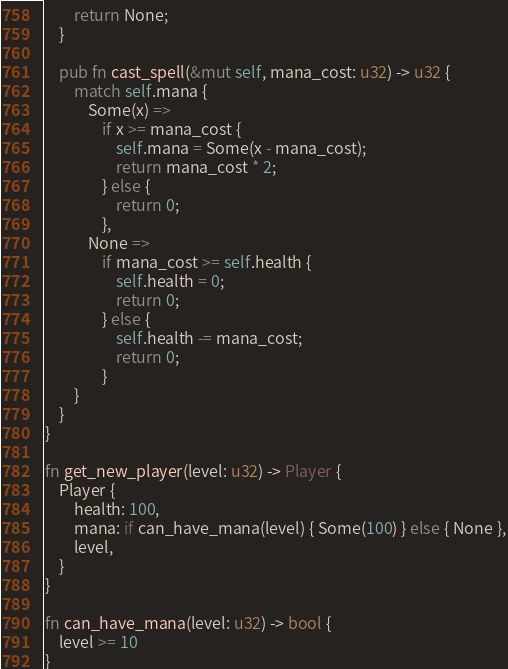<code> <loc_0><loc_0><loc_500><loc_500><_Rust_>        return None;
    }

    pub fn cast_spell(&mut self, mana_cost: u32) -> u32 {
        match self.mana {
            Some(x) =>
                if x >= mana_cost {
                    self.mana = Some(x - mana_cost);
                    return mana_cost * 2;
                } else {
                    return 0;
                },
            None =>
                if mana_cost >= self.health {
                    self.health = 0;
                    return 0;
                } else {
                    self.health -= mana_cost;
                    return 0;
                }
        }
    }
}

fn get_new_player(level: u32) -> Player {
    Player {
        health: 100,
        mana: if can_have_mana(level) { Some(100) } else { None },
        level,
    }
}

fn can_have_mana(level: u32) -> bool {
    level >= 10
}
</code> 